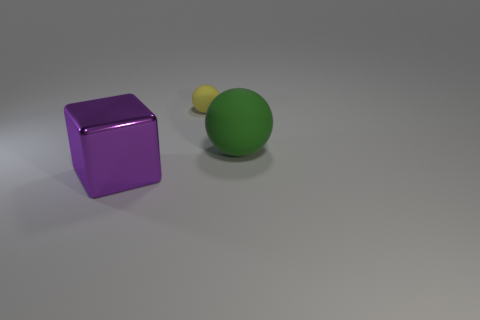Subtract all red spheres. Subtract all red blocks. How many spheres are left? 2 Subtract all balls. How many objects are left? 1 Subtract all yellow cylinders. How many blue cubes are left? 0 Subtract all small purple cylinders. Subtract all green balls. How many objects are left? 2 Add 2 purple things. How many purple things are left? 3 Add 1 green things. How many green things exist? 2 Add 1 small yellow balls. How many objects exist? 4 Subtract 0 blue cylinders. How many objects are left? 3 